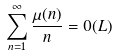<formula> <loc_0><loc_0><loc_500><loc_500>\sum _ { n = 1 } ^ { \infty } \frac { \mu ( n ) } { n } = 0 ( L )</formula> 